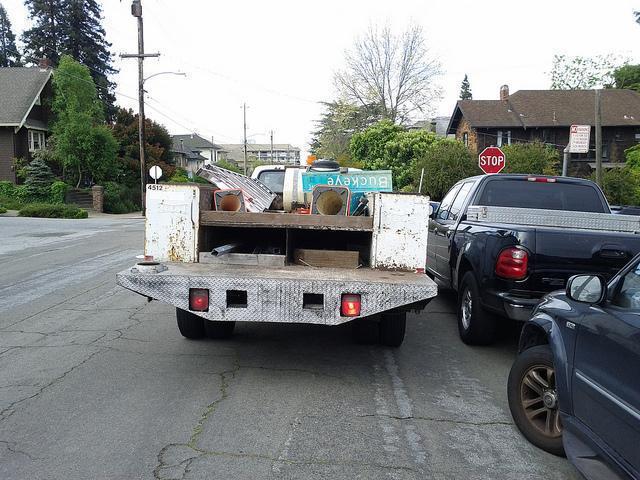Asphalts are used to construct what?
Select the accurate response from the four choices given to answer the question.
Options: House, roads, building, harbor. Roads. 